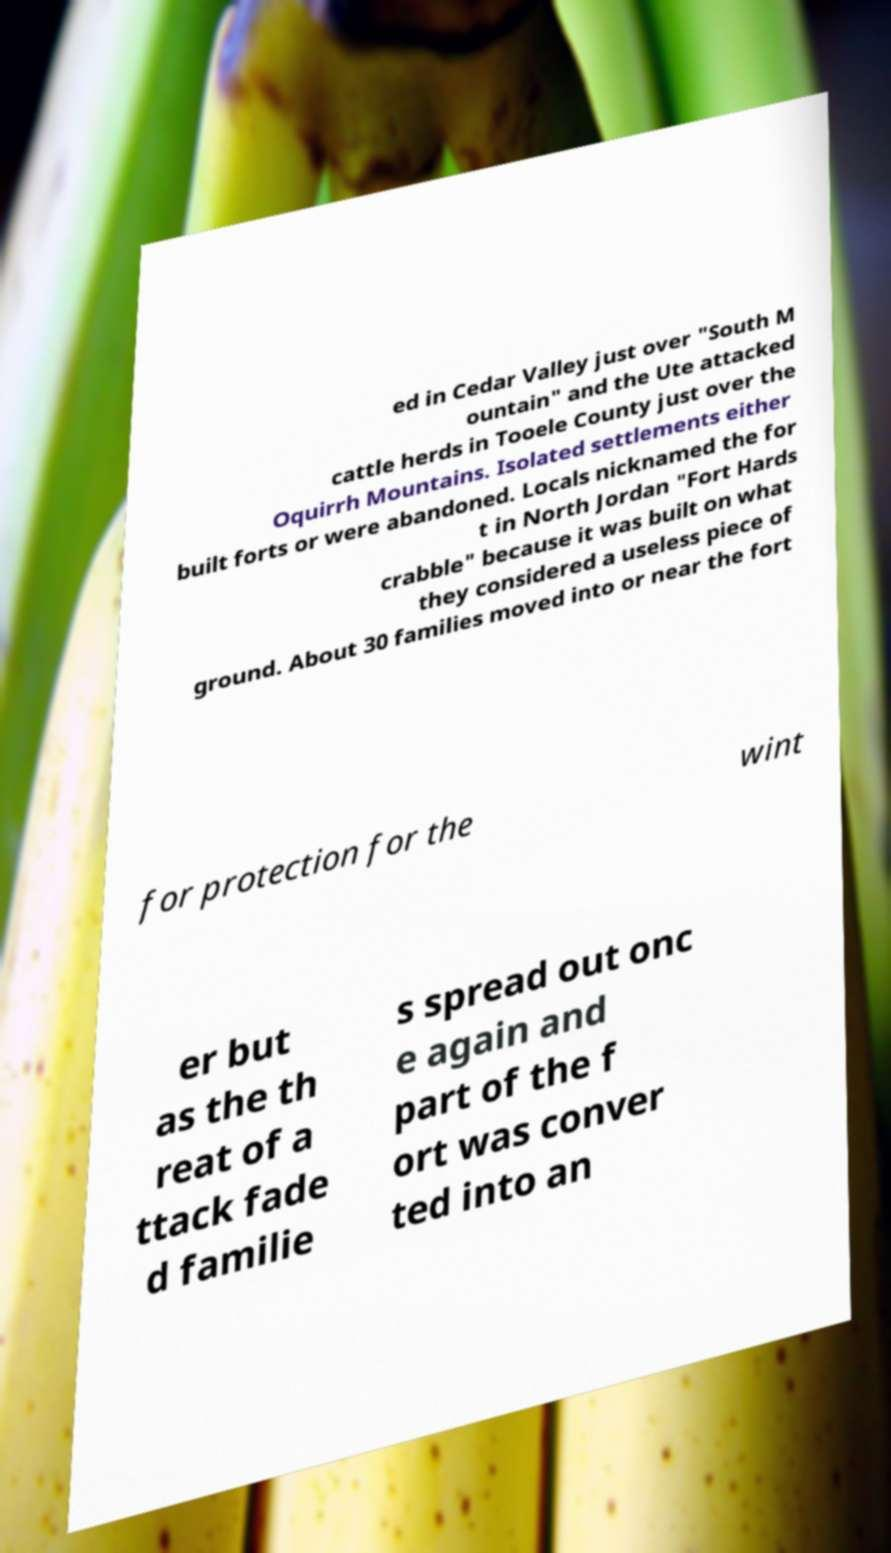What messages or text are displayed in this image? I need them in a readable, typed format. ed in Cedar Valley just over "South M ountain" and the Ute attacked cattle herds in Tooele County just over the Oquirrh Mountains. Isolated settlements either built forts or were abandoned. Locals nicknamed the for t in North Jordan "Fort Hards crabble" because it was built on what they considered a useless piece of ground. About 30 families moved into or near the fort for protection for the wint er but as the th reat of a ttack fade d familie s spread out onc e again and part of the f ort was conver ted into an 